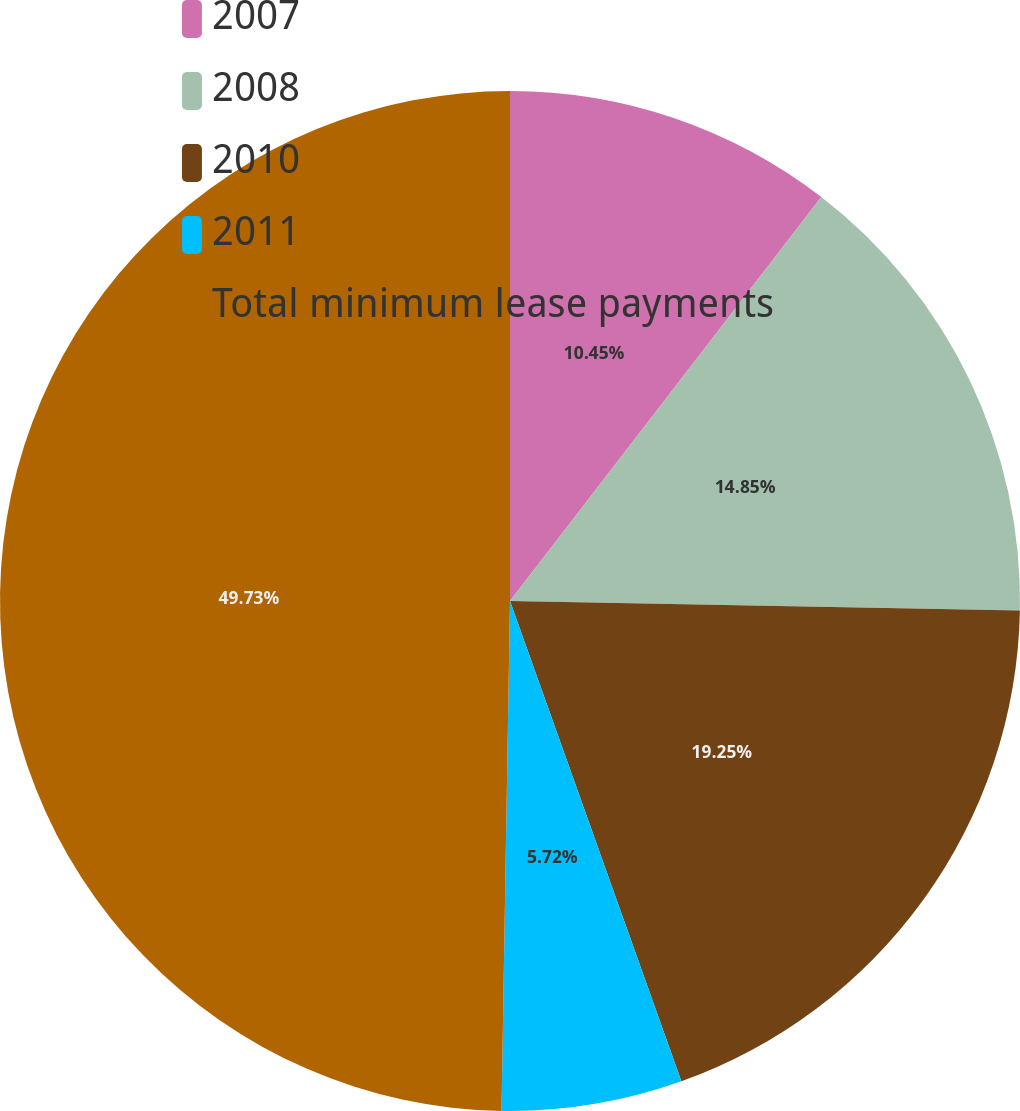Convert chart to OTSL. <chart><loc_0><loc_0><loc_500><loc_500><pie_chart><fcel>2007<fcel>2008<fcel>2010<fcel>2011<fcel>Total minimum lease payments<nl><fcel>10.45%<fcel>14.85%<fcel>19.25%<fcel>5.72%<fcel>49.74%<nl></chart> 